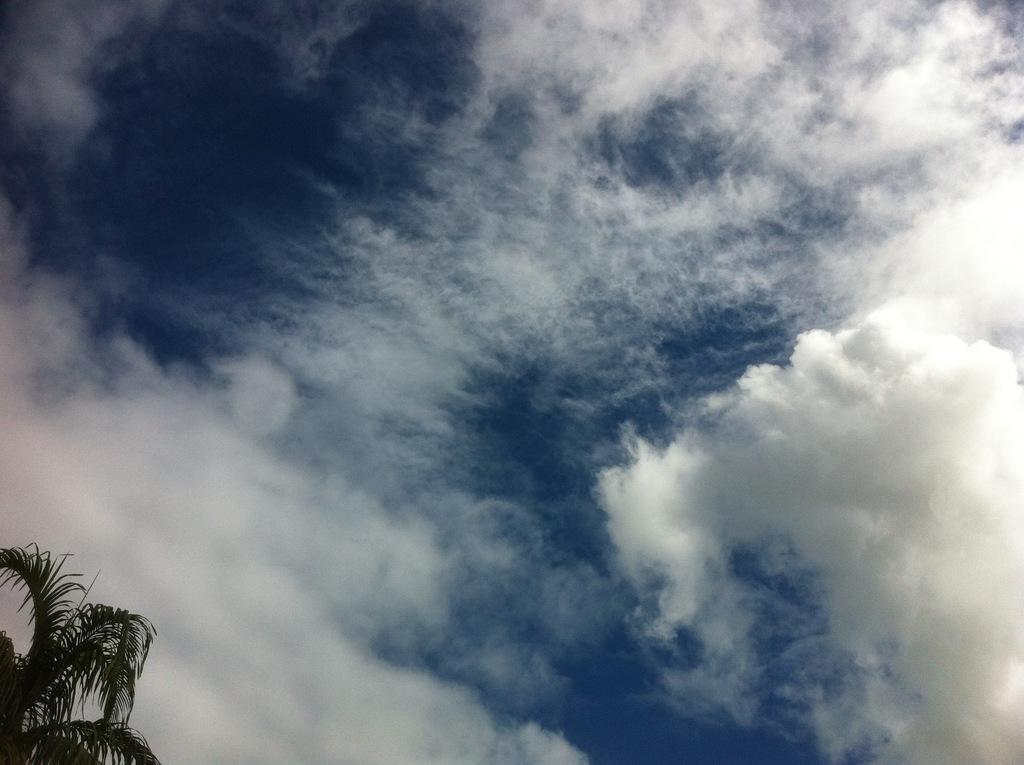How would you summarize this image in a sentence or two? In this image we can see a tree, the sky is cloudy. 